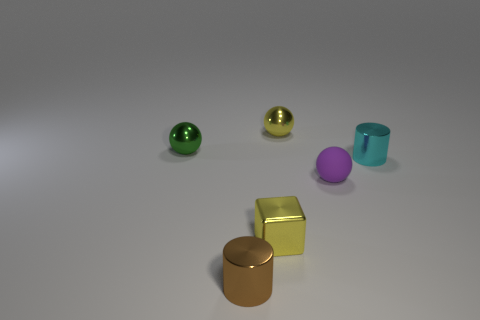Add 3 green metal blocks. How many objects exist? 9 Subtract all blocks. How many objects are left? 5 Add 2 cyan shiny objects. How many cyan shiny objects are left? 3 Add 6 small metal balls. How many small metal balls exist? 8 Subtract 0 red cubes. How many objects are left? 6 Subtract all small cyan metal spheres. Subtract all small things. How many objects are left? 0 